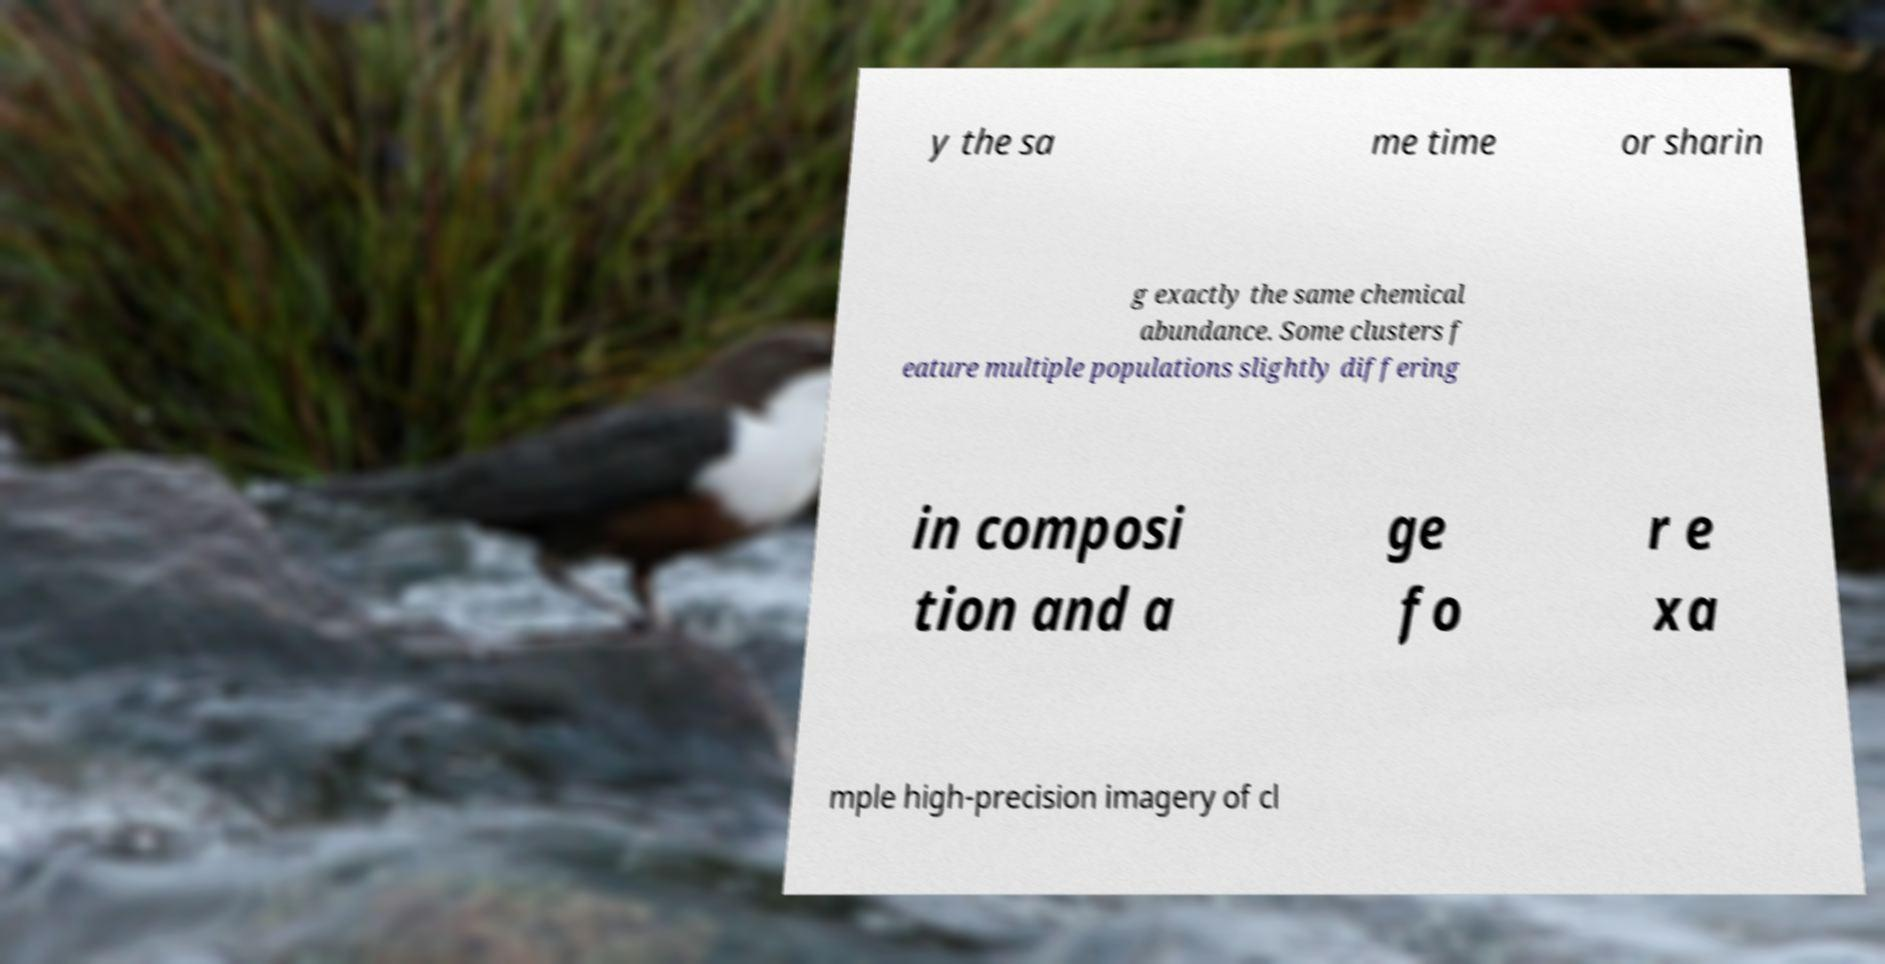Can you accurately transcribe the text from the provided image for me? y the sa me time or sharin g exactly the same chemical abundance. Some clusters f eature multiple populations slightly differing in composi tion and a ge fo r e xa mple high-precision imagery of cl 